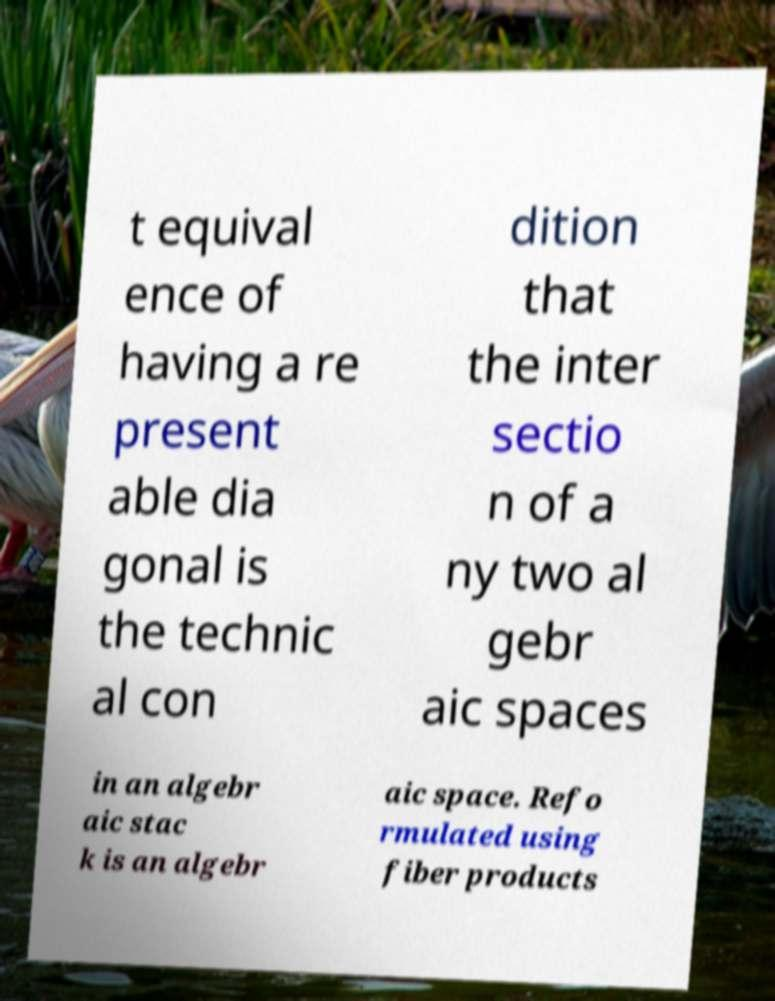Please read and relay the text visible in this image. What does it say? t equival ence of having a re present able dia gonal is the technic al con dition that the inter sectio n of a ny two al gebr aic spaces in an algebr aic stac k is an algebr aic space. Refo rmulated using fiber products 